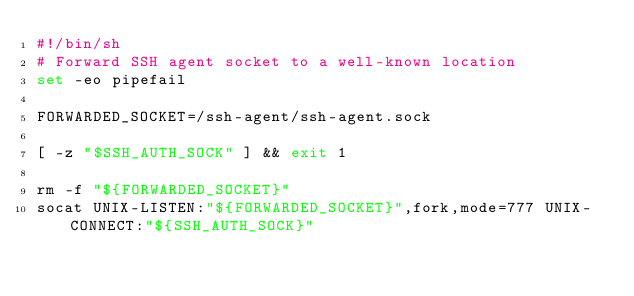Convert code to text. <code><loc_0><loc_0><loc_500><loc_500><_Bash_>#!/bin/sh
# Forward SSH agent socket to a well-known location
set -eo pipefail

FORWARDED_SOCKET=/ssh-agent/ssh-agent.sock

[ -z "$SSH_AUTH_SOCK" ] && exit 1

rm -f "${FORWARDED_SOCKET}"
socat UNIX-LISTEN:"${FORWARDED_SOCKET}",fork,mode=777 UNIX-CONNECT:"${SSH_AUTH_SOCK}"
</code> 